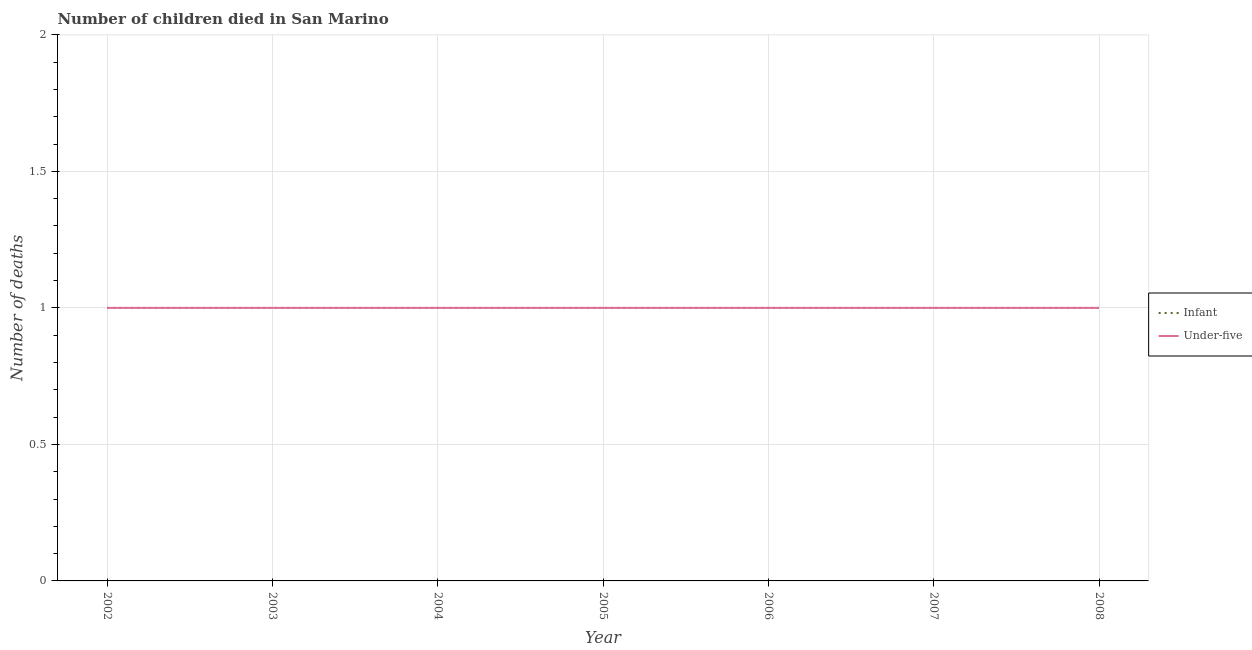What is the number of under-five deaths in 2007?
Offer a terse response. 1. Across all years, what is the maximum number of infant deaths?
Your response must be concise. 1. Across all years, what is the minimum number of infant deaths?
Ensure brevity in your answer.  1. In which year was the number of infant deaths maximum?
Provide a succinct answer. 2002. In which year was the number of under-five deaths minimum?
Make the answer very short. 2002. What is the total number of under-five deaths in the graph?
Your response must be concise. 7. What is the difference between the number of under-five deaths in 2003 and the number of infant deaths in 2007?
Provide a succinct answer. 0. What is the average number of infant deaths per year?
Your answer should be compact. 1. In the year 2002, what is the difference between the number of under-five deaths and number of infant deaths?
Provide a short and direct response. 0. In how many years, is the number of under-five deaths greater than 0.8?
Ensure brevity in your answer.  7. Is the number of under-five deaths in 2004 less than that in 2008?
Your answer should be compact. No. Is the sum of the number of infant deaths in 2007 and 2008 greater than the maximum number of under-five deaths across all years?
Your answer should be compact. Yes. Does the number of infant deaths monotonically increase over the years?
Offer a terse response. No. Is the number of infant deaths strictly less than the number of under-five deaths over the years?
Provide a succinct answer. No. How many lines are there?
Provide a succinct answer. 2. How many years are there in the graph?
Make the answer very short. 7. Are the values on the major ticks of Y-axis written in scientific E-notation?
Your response must be concise. No. Where does the legend appear in the graph?
Provide a short and direct response. Center right. What is the title of the graph?
Keep it short and to the point. Number of children died in San Marino. Does "Fixed telephone" appear as one of the legend labels in the graph?
Your answer should be very brief. No. What is the label or title of the X-axis?
Ensure brevity in your answer.  Year. What is the label or title of the Y-axis?
Your response must be concise. Number of deaths. What is the Number of deaths in Under-five in 2002?
Provide a succinct answer. 1. What is the Number of deaths in Infant in 2003?
Your answer should be compact. 1. What is the Number of deaths in Under-five in 2004?
Ensure brevity in your answer.  1. What is the Number of deaths in Under-five in 2006?
Your response must be concise. 1. What is the Number of deaths of Infant in 2007?
Keep it short and to the point. 1. What is the Number of deaths of Under-five in 2007?
Ensure brevity in your answer.  1. What is the Number of deaths of Infant in 2008?
Provide a short and direct response. 1. What is the Number of deaths in Under-five in 2008?
Provide a short and direct response. 1. Across all years, what is the maximum Number of deaths in Infant?
Keep it short and to the point. 1. Across all years, what is the minimum Number of deaths of Infant?
Make the answer very short. 1. What is the total Number of deaths of Infant in the graph?
Your answer should be very brief. 7. What is the total Number of deaths in Under-five in the graph?
Make the answer very short. 7. What is the difference between the Number of deaths in Infant in 2002 and that in 2003?
Your answer should be very brief. 0. What is the difference between the Number of deaths in Under-five in 2002 and that in 2004?
Make the answer very short. 0. What is the difference between the Number of deaths of Under-five in 2002 and that in 2005?
Offer a terse response. 0. What is the difference between the Number of deaths in Infant in 2002 and that in 2006?
Your answer should be compact. 0. What is the difference between the Number of deaths of Infant in 2002 and that in 2007?
Your response must be concise. 0. What is the difference between the Number of deaths in Infant in 2002 and that in 2008?
Make the answer very short. 0. What is the difference between the Number of deaths in Infant in 2003 and that in 2004?
Offer a terse response. 0. What is the difference between the Number of deaths in Under-five in 2003 and that in 2004?
Give a very brief answer. 0. What is the difference between the Number of deaths in Infant in 2003 and that in 2005?
Your answer should be very brief. 0. What is the difference between the Number of deaths of Under-five in 2003 and that in 2005?
Your answer should be compact. 0. What is the difference between the Number of deaths in Infant in 2003 and that in 2007?
Your response must be concise. 0. What is the difference between the Number of deaths of Infant in 2003 and that in 2008?
Offer a terse response. 0. What is the difference between the Number of deaths in Under-five in 2003 and that in 2008?
Your response must be concise. 0. What is the difference between the Number of deaths of Under-five in 2004 and that in 2006?
Give a very brief answer. 0. What is the difference between the Number of deaths of Under-five in 2004 and that in 2007?
Your answer should be very brief. 0. What is the difference between the Number of deaths of Infant in 2004 and that in 2008?
Offer a terse response. 0. What is the difference between the Number of deaths in Under-five in 2005 and that in 2006?
Your answer should be very brief. 0. What is the difference between the Number of deaths of Under-five in 2005 and that in 2007?
Keep it short and to the point. 0. What is the difference between the Number of deaths of Infant in 2005 and that in 2008?
Ensure brevity in your answer.  0. What is the difference between the Number of deaths of Under-five in 2006 and that in 2008?
Offer a very short reply. 0. What is the difference between the Number of deaths in Under-five in 2007 and that in 2008?
Give a very brief answer. 0. What is the difference between the Number of deaths in Infant in 2002 and the Number of deaths in Under-five in 2003?
Your response must be concise. 0. What is the difference between the Number of deaths in Infant in 2002 and the Number of deaths in Under-five in 2006?
Offer a very short reply. 0. What is the difference between the Number of deaths of Infant in 2002 and the Number of deaths of Under-five in 2007?
Give a very brief answer. 0. What is the difference between the Number of deaths in Infant in 2002 and the Number of deaths in Under-five in 2008?
Your response must be concise. 0. What is the difference between the Number of deaths of Infant in 2003 and the Number of deaths of Under-five in 2004?
Offer a terse response. 0. What is the difference between the Number of deaths of Infant in 2003 and the Number of deaths of Under-five in 2005?
Your answer should be very brief. 0. What is the difference between the Number of deaths in Infant in 2003 and the Number of deaths in Under-five in 2007?
Ensure brevity in your answer.  0. What is the difference between the Number of deaths of Infant in 2004 and the Number of deaths of Under-five in 2006?
Make the answer very short. 0. What is the difference between the Number of deaths of Infant in 2004 and the Number of deaths of Under-five in 2007?
Make the answer very short. 0. What is the difference between the Number of deaths in Infant in 2004 and the Number of deaths in Under-five in 2008?
Keep it short and to the point. 0. What is the difference between the Number of deaths of Infant in 2005 and the Number of deaths of Under-five in 2007?
Offer a terse response. 0. What is the difference between the Number of deaths in Infant in 2005 and the Number of deaths in Under-five in 2008?
Keep it short and to the point. 0. What is the difference between the Number of deaths of Infant in 2007 and the Number of deaths of Under-five in 2008?
Your response must be concise. 0. What is the average Number of deaths of Under-five per year?
Provide a short and direct response. 1. In the year 2002, what is the difference between the Number of deaths in Infant and Number of deaths in Under-five?
Give a very brief answer. 0. In the year 2003, what is the difference between the Number of deaths of Infant and Number of deaths of Under-five?
Offer a terse response. 0. In the year 2005, what is the difference between the Number of deaths of Infant and Number of deaths of Under-five?
Offer a terse response. 0. In the year 2006, what is the difference between the Number of deaths in Infant and Number of deaths in Under-five?
Keep it short and to the point. 0. In the year 2008, what is the difference between the Number of deaths in Infant and Number of deaths in Under-five?
Offer a very short reply. 0. What is the ratio of the Number of deaths of Under-five in 2002 to that in 2003?
Make the answer very short. 1. What is the ratio of the Number of deaths in Infant in 2002 to that in 2004?
Your response must be concise. 1. What is the ratio of the Number of deaths in Under-five in 2002 to that in 2004?
Give a very brief answer. 1. What is the ratio of the Number of deaths of Infant in 2002 to that in 2005?
Give a very brief answer. 1. What is the ratio of the Number of deaths of Under-five in 2002 to that in 2005?
Keep it short and to the point. 1. What is the ratio of the Number of deaths in Infant in 2002 to that in 2008?
Ensure brevity in your answer.  1. What is the ratio of the Number of deaths in Under-five in 2002 to that in 2008?
Offer a terse response. 1. What is the ratio of the Number of deaths of Infant in 2003 to that in 2004?
Provide a short and direct response. 1. What is the ratio of the Number of deaths in Infant in 2003 to that in 2006?
Offer a terse response. 1. What is the ratio of the Number of deaths of Under-five in 2003 to that in 2006?
Your answer should be very brief. 1. What is the ratio of the Number of deaths in Infant in 2003 to that in 2007?
Your response must be concise. 1. What is the ratio of the Number of deaths in Under-five in 2003 to that in 2008?
Provide a succinct answer. 1. What is the ratio of the Number of deaths in Under-five in 2004 to that in 2006?
Provide a short and direct response. 1. What is the ratio of the Number of deaths in Infant in 2004 to that in 2007?
Provide a short and direct response. 1. What is the ratio of the Number of deaths in Under-five in 2004 to that in 2007?
Ensure brevity in your answer.  1. What is the ratio of the Number of deaths of Under-five in 2004 to that in 2008?
Offer a terse response. 1. What is the ratio of the Number of deaths in Infant in 2005 to that in 2007?
Provide a short and direct response. 1. What is the ratio of the Number of deaths of Infant in 2005 to that in 2008?
Provide a short and direct response. 1. What is the ratio of the Number of deaths in Infant in 2006 to that in 2008?
Provide a succinct answer. 1. What is the ratio of the Number of deaths of Infant in 2007 to that in 2008?
Provide a short and direct response. 1. What is the ratio of the Number of deaths in Under-five in 2007 to that in 2008?
Offer a very short reply. 1. What is the difference between the highest and the second highest Number of deaths of Infant?
Your response must be concise. 0. What is the difference between the highest and the second highest Number of deaths in Under-five?
Provide a succinct answer. 0. 